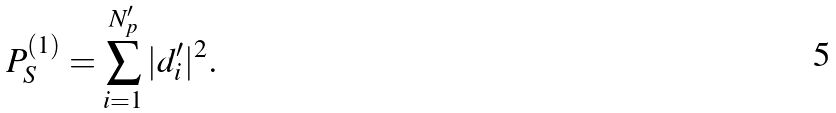<formula> <loc_0><loc_0><loc_500><loc_500>P ^ { ( 1 ) } _ { S } = \sum ^ { N ^ { \prime } _ { p } } _ { i = 1 } | d ^ { \prime } _ { i } | ^ { 2 } .</formula> 